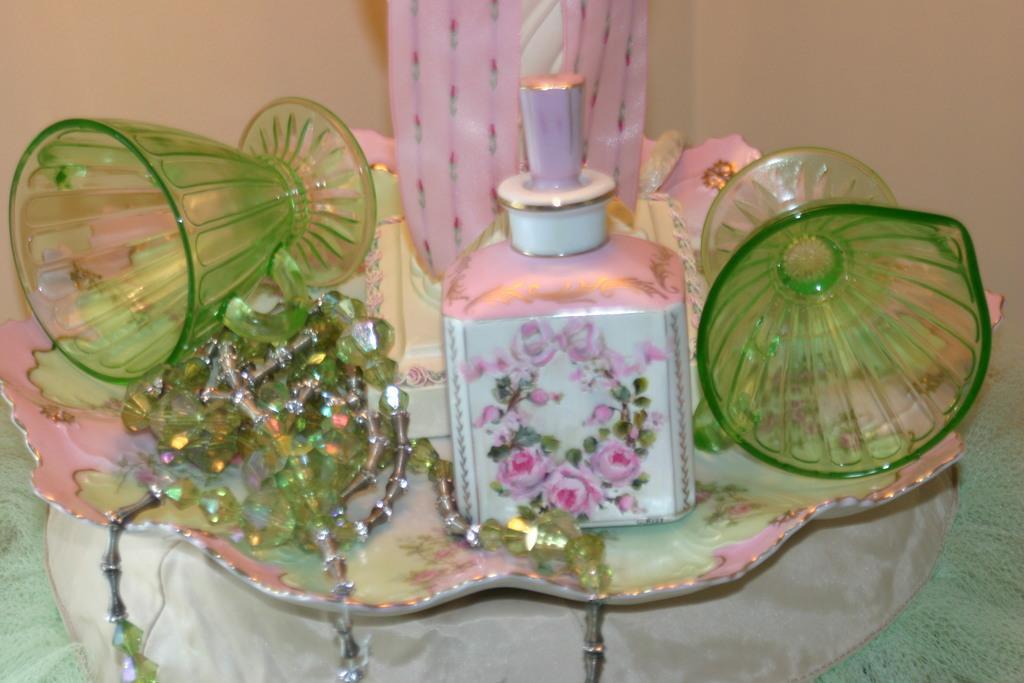Can you describe this image briefly? In this image we can see a perfume bottle, two green color glasses, chain present in the plate which is on the table. In the background we can see the plain wall. 